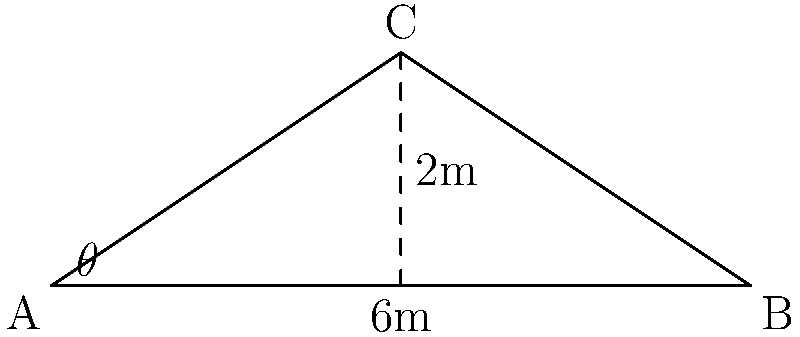In a traditional Japanese tiled roof, the angle of inclination is crucial for proper water drainage. Given the side-view diagram of a roof section, where the base is 6 meters wide and the peak height is 2 meters, what is the angle of inclination (θ) of the roof? To find the angle of inclination (θ), we can use basic trigonometry:

1. The roof forms a right-angled triangle with the following dimensions:
   - Base (half of the total width): 3 meters
   - Height: 2 meters
   - Hypotenuse: the roof surface

2. We can use the tangent function to find the angle:
   
   $$\tan(\theta) = \frac{\text{opposite}}{\text{adjacent}} = \frac{\text{height}}{\text{half base}}$$

3. Substituting the values:

   $$\tan(\theta) = \frac{2}{3}$$

4. To find θ, we need to use the inverse tangent (arctan or tan^(-1)):

   $$\theta = \tan^{-1}\left(\frac{2}{3}\right)$$

5. Using a calculator or mathematical software:

   $$\theta \approx 33.69^\circ$$

6. Rounding to the nearest degree:

   $$\theta \approx 34^\circ$$

This angle of approximately 34° is typical for many traditional Japanese tiled roofs, as it provides an effective balance between water drainage and stability.
Answer: 34° 